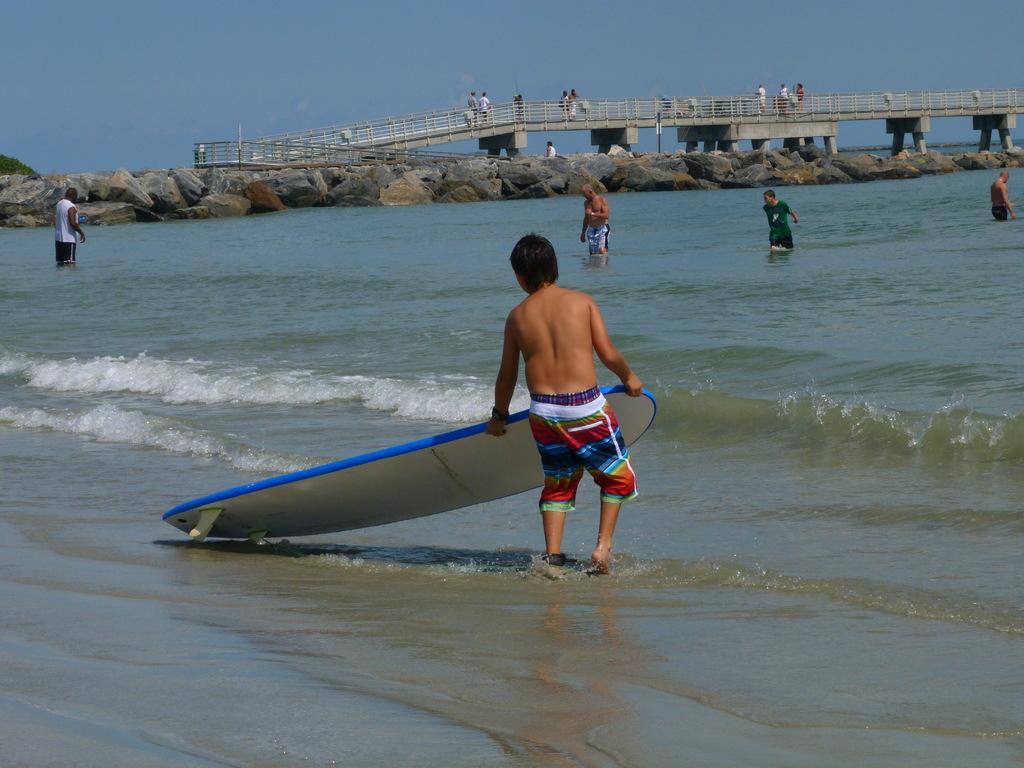Can you describe this image briefly? In this image I can see there are group of people who are in the water and some are on the bridge. 